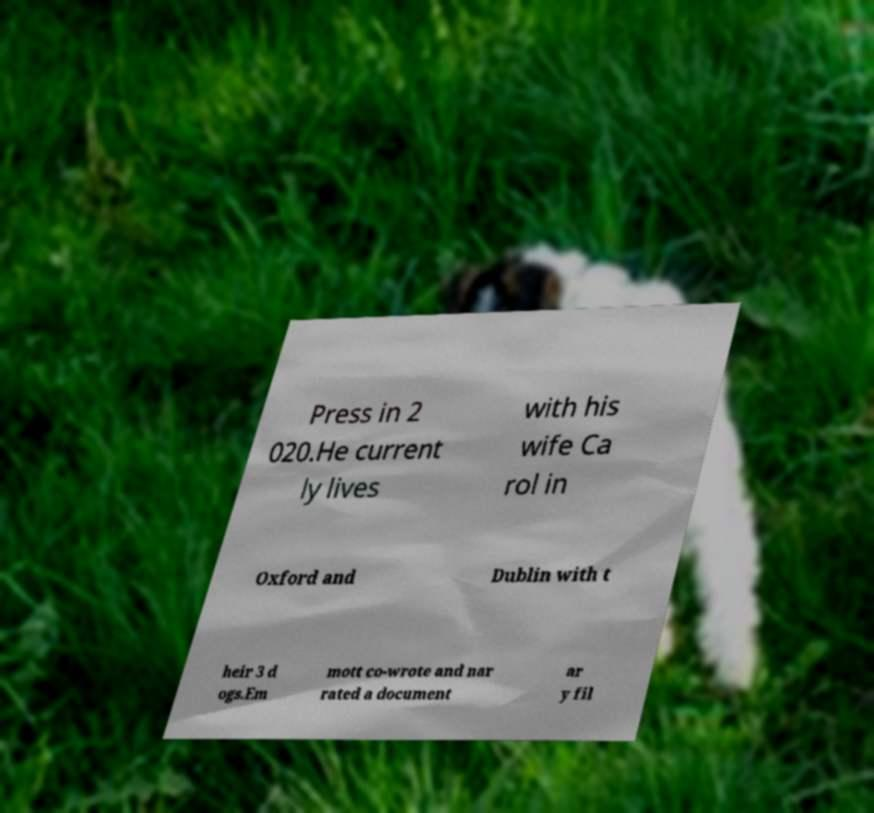For documentation purposes, I need the text within this image transcribed. Could you provide that? Press in 2 020.He current ly lives with his wife Ca rol in Oxford and Dublin with t heir 3 d ogs.Em mott co-wrote and nar rated a document ar y fil 